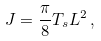Convert formula to latex. <formula><loc_0><loc_0><loc_500><loc_500>J = \frac { \pi } { 8 } T _ { s } L ^ { 2 } \, ,</formula> 